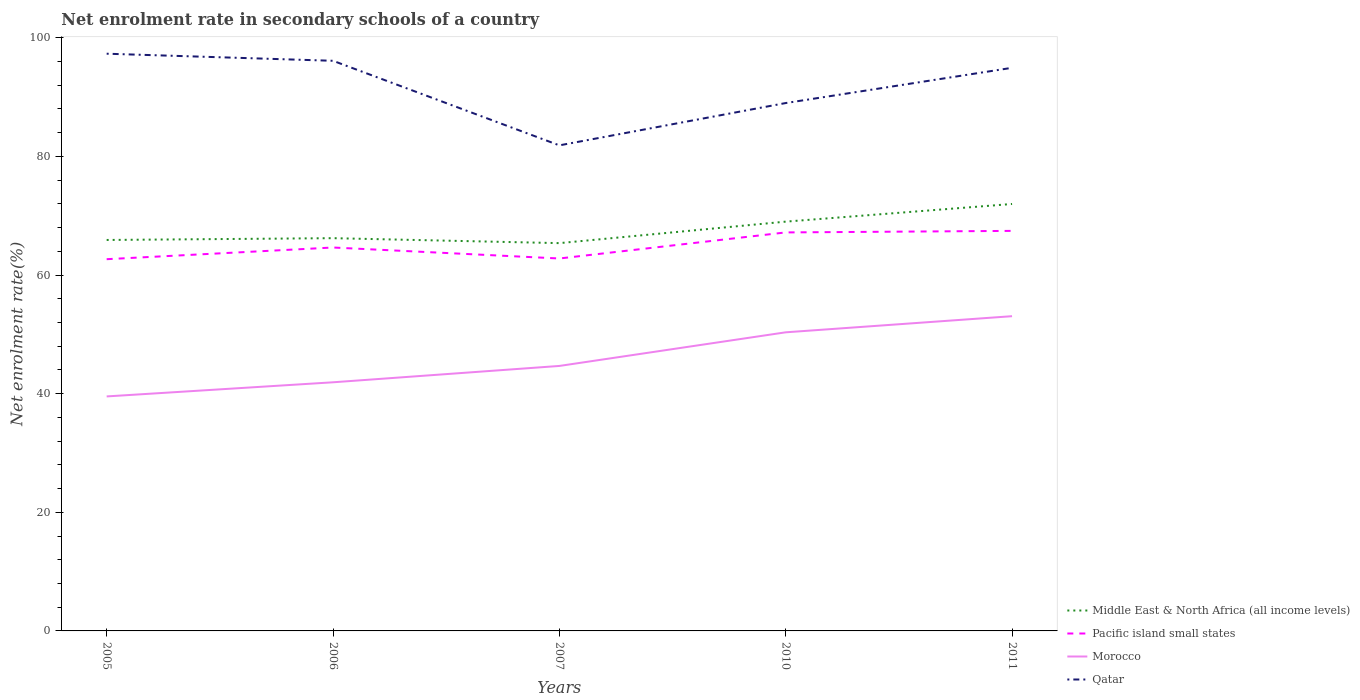How many different coloured lines are there?
Make the answer very short. 4. Does the line corresponding to Qatar intersect with the line corresponding to Morocco?
Provide a succinct answer. No. Across all years, what is the maximum net enrolment rate in secondary schools in Qatar?
Your answer should be compact. 81.87. In which year was the net enrolment rate in secondary schools in Morocco maximum?
Make the answer very short. 2005. What is the total net enrolment rate in secondary schools in Qatar in the graph?
Give a very brief answer. 2.38. What is the difference between the highest and the second highest net enrolment rate in secondary schools in Morocco?
Keep it short and to the point. 13.53. Is the net enrolment rate in secondary schools in Pacific island small states strictly greater than the net enrolment rate in secondary schools in Morocco over the years?
Make the answer very short. No. How many lines are there?
Your answer should be very brief. 4. What is the difference between two consecutive major ticks on the Y-axis?
Provide a short and direct response. 20. Are the values on the major ticks of Y-axis written in scientific E-notation?
Provide a short and direct response. No. Does the graph contain any zero values?
Keep it short and to the point. No. Does the graph contain grids?
Give a very brief answer. No. What is the title of the graph?
Offer a terse response. Net enrolment rate in secondary schools of a country. Does "Trinidad and Tobago" appear as one of the legend labels in the graph?
Your answer should be very brief. No. What is the label or title of the Y-axis?
Your answer should be very brief. Net enrolment rate(%). What is the Net enrolment rate(%) of Middle East & North Africa (all income levels) in 2005?
Provide a succinct answer. 65.92. What is the Net enrolment rate(%) in Pacific island small states in 2005?
Your response must be concise. 62.68. What is the Net enrolment rate(%) of Morocco in 2005?
Your answer should be very brief. 39.54. What is the Net enrolment rate(%) of Qatar in 2005?
Your response must be concise. 97.32. What is the Net enrolment rate(%) in Middle East & North Africa (all income levels) in 2006?
Make the answer very short. 66.22. What is the Net enrolment rate(%) in Pacific island small states in 2006?
Provide a short and direct response. 64.65. What is the Net enrolment rate(%) in Morocco in 2006?
Your answer should be very brief. 41.92. What is the Net enrolment rate(%) of Qatar in 2006?
Give a very brief answer. 96.13. What is the Net enrolment rate(%) of Middle East & North Africa (all income levels) in 2007?
Make the answer very short. 65.38. What is the Net enrolment rate(%) in Pacific island small states in 2007?
Your answer should be very brief. 62.79. What is the Net enrolment rate(%) of Morocco in 2007?
Provide a short and direct response. 44.68. What is the Net enrolment rate(%) of Qatar in 2007?
Give a very brief answer. 81.87. What is the Net enrolment rate(%) in Middle East & North Africa (all income levels) in 2010?
Provide a short and direct response. 69.01. What is the Net enrolment rate(%) in Pacific island small states in 2010?
Your response must be concise. 67.19. What is the Net enrolment rate(%) of Morocco in 2010?
Give a very brief answer. 50.35. What is the Net enrolment rate(%) of Qatar in 2010?
Your answer should be compact. 89. What is the Net enrolment rate(%) in Middle East & North Africa (all income levels) in 2011?
Offer a terse response. 71.99. What is the Net enrolment rate(%) in Pacific island small states in 2011?
Ensure brevity in your answer.  67.45. What is the Net enrolment rate(%) of Morocco in 2011?
Give a very brief answer. 53.07. What is the Net enrolment rate(%) of Qatar in 2011?
Offer a very short reply. 94.95. Across all years, what is the maximum Net enrolment rate(%) of Middle East & North Africa (all income levels)?
Provide a succinct answer. 71.99. Across all years, what is the maximum Net enrolment rate(%) in Pacific island small states?
Your answer should be compact. 67.45. Across all years, what is the maximum Net enrolment rate(%) in Morocco?
Your response must be concise. 53.07. Across all years, what is the maximum Net enrolment rate(%) of Qatar?
Offer a terse response. 97.32. Across all years, what is the minimum Net enrolment rate(%) in Middle East & North Africa (all income levels)?
Your response must be concise. 65.38. Across all years, what is the minimum Net enrolment rate(%) in Pacific island small states?
Make the answer very short. 62.68. Across all years, what is the minimum Net enrolment rate(%) in Morocco?
Give a very brief answer. 39.54. Across all years, what is the minimum Net enrolment rate(%) in Qatar?
Give a very brief answer. 81.87. What is the total Net enrolment rate(%) in Middle East & North Africa (all income levels) in the graph?
Keep it short and to the point. 338.52. What is the total Net enrolment rate(%) of Pacific island small states in the graph?
Your answer should be very brief. 324.76. What is the total Net enrolment rate(%) in Morocco in the graph?
Give a very brief answer. 229.55. What is the total Net enrolment rate(%) in Qatar in the graph?
Provide a short and direct response. 459.27. What is the difference between the Net enrolment rate(%) of Middle East & North Africa (all income levels) in 2005 and that in 2006?
Offer a very short reply. -0.3. What is the difference between the Net enrolment rate(%) in Pacific island small states in 2005 and that in 2006?
Your answer should be very brief. -1.97. What is the difference between the Net enrolment rate(%) of Morocco in 2005 and that in 2006?
Your response must be concise. -2.38. What is the difference between the Net enrolment rate(%) of Qatar in 2005 and that in 2006?
Provide a short and direct response. 1.19. What is the difference between the Net enrolment rate(%) of Middle East & North Africa (all income levels) in 2005 and that in 2007?
Provide a succinct answer. 0.53. What is the difference between the Net enrolment rate(%) of Pacific island small states in 2005 and that in 2007?
Make the answer very short. -0.12. What is the difference between the Net enrolment rate(%) in Morocco in 2005 and that in 2007?
Keep it short and to the point. -5.14. What is the difference between the Net enrolment rate(%) of Qatar in 2005 and that in 2007?
Your response must be concise. 15.45. What is the difference between the Net enrolment rate(%) of Middle East & North Africa (all income levels) in 2005 and that in 2010?
Your answer should be very brief. -3.09. What is the difference between the Net enrolment rate(%) of Pacific island small states in 2005 and that in 2010?
Ensure brevity in your answer.  -4.51. What is the difference between the Net enrolment rate(%) in Morocco in 2005 and that in 2010?
Your answer should be compact. -10.81. What is the difference between the Net enrolment rate(%) in Qatar in 2005 and that in 2010?
Keep it short and to the point. 8.32. What is the difference between the Net enrolment rate(%) in Middle East & North Africa (all income levels) in 2005 and that in 2011?
Your answer should be compact. -6.07. What is the difference between the Net enrolment rate(%) in Pacific island small states in 2005 and that in 2011?
Your answer should be compact. -4.77. What is the difference between the Net enrolment rate(%) in Morocco in 2005 and that in 2011?
Provide a short and direct response. -13.53. What is the difference between the Net enrolment rate(%) in Qatar in 2005 and that in 2011?
Offer a very short reply. 2.38. What is the difference between the Net enrolment rate(%) in Middle East & North Africa (all income levels) in 2006 and that in 2007?
Offer a very short reply. 0.84. What is the difference between the Net enrolment rate(%) of Pacific island small states in 2006 and that in 2007?
Give a very brief answer. 1.85. What is the difference between the Net enrolment rate(%) of Morocco in 2006 and that in 2007?
Keep it short and to the point. -2.76. What is the difference between the Net enrolment rate(%) of Qatar in 2006 and that in 2007?
Make the answer very short. 14.26. What is the difference between the Net enrolment rate(%) of Middle East & North Africa (all income levels) in 2006 and that in 2010?
Provide a short and direct response. -2.79. What is the difference between the Net enrolment rate(%) in Pacific island small states in 2006 and that in 2010?
Offer a terse response. -2.54. What is the difference between the Net enrolment rate(%) in Morocco in 2006 and that in 2010?
Provide a succinct answer. -8.43. What is the difference between the Net enrolment rate(%) of Qatar in 2006 and that in 2010?
Your response must be concise. 7.12. What is the difference between the Net enrolment rate(%) of Middle East & North Africa (all income levels) in 2006 and that in 2011?
Your response must be concise. -5.77. What is the difference between the Net enrolment rate(%) in Pacific island small states in 2006 and that in 2011?
Ensure brevity in your answer.  -2.8. What is the difference between the Net enrolment rate(%) of Morocco in 2006 and that in 2011?
Keep it short and to the point. -11.15. What is the difference between the Net enrolment rate(%) in Qatar in 2006 and that in 2011?
Ensure brevity in your answer.  1.18. What is the difference between the Net enrolment rate(%) in Middle East & North Africa (all income levels) in 2007 and that in 2010?
Offer a very short reply. -3.63. What is the difference between the Net enrolment rate(%) in Pacific island small states in 2007 and that in 2010?
Keep it short and to the point. -4.4. What is the difference between the Net enrolment rate(%) of Morocco in 2007 and that in 2010?
Your answer should be very brief. -5.67. What is the difference between the Net enrolment rate(%) in Qatar in 2007 and that in 2010?
Offer a very short reply. -7.13. What is the difference between the Net enrolment rate(%) in Middle East & North Africa (all income levels) in 2007 and that in 2011?
Make the answer very short. -6.6. What is the difference between the Net enrolment rate(%) of Pacific island small states in 2007 and that in 2011?
Your answer should be very brief. -4.66. What is the difference between the Net enrolment rate(%) of Morocco in 2007 and that in 2011?
Offer a terse response. -8.39. What is the difference between the Net enrolment rate(%) in Qatar in 2007 and that in 2011?
Keep it short and to the point. -13.08. What is the difference between the Net enrolment rate(%) of Middle East & North Africa (all income levels) in 2010 and that in 2011?
Offer a terse response. -2.98. What is the difference between the Net enrolment rate(%) in Pacific island small states in 2010 and that in 2011?
Ensure brevity in your answer.  -0.26. What is the difference between the Net enrolment rate(%) of Morocco in 2010 and that in 2011?
Offer a terse response. -2.72. What is the difference between the Net enrolment rate(%) of Qatar in 2010 and that in 2011?
Keep it short and to the point. -5.94. What is the difference between the Net enrolment rate(%) in Middle East & North Africa (all income levels) in 2005 and the Net enrolment rate(%) in Pacific island small states in 2006?
Offer a terse response. 1.27. What is the difference between the Net enrolment rate(%) in Middle East & North Africa (all income levels) in 2005 and the Net enrolment rate(%) in Morocco in 2006?
Provide a succinct answer. 24. What is the difference between the Net enrolment rate(%) of Middle East & North Africa (all income levels) in 2005 and the Net enrolment rate(%) of Qatar in 2006?
Give a very brief answer. -30.21. What is the difference between the Net enrolment rate(%) of Pacific island small states in 2005 and the Net enrolment rate(%) of Morocco in 2006?
Offer a terse response. 20.76. What is the difference between the Net enrolment rate(%) of Pacific island small states in 2005 and the Net enrolment rate(%) of Qatar in 2006?
Provide a short and direct response. -33.45. What is the difference between the Net enrolment rate(%) in Morocco in 2005 and the Net enrolment rate(%) in Qatar in 2006?
Make the answer very short. -56.59. What is the difference between the Net enrolment rate(%) in Middle East & North Africa (all income levels) in 2005 and the Net enrolment rate(%) in Pacific island small states in 2007?
Ensure brevity in your answer.  3.12. What is the difference between the Net enrolment rate(%) of Middle East & North Africa (all income levels) in 2005 and the Net enrolment rate(%) of Morocco in 2007?
Keep it short and to the point. 21.24. What is the difference between the Net enrolment rate(%) in Middle East & North Africa (all income levels) in 2005 and the Net enrolment rate(%) in Qatar in 2007?
Make the answer very short. -15.95. What is the difference between the Net enrolment rate(%) of Pacific island small states in 2005 and the Net enrolment rate(%) of Morocco in 2007?
Provide a succinct answer. 18. What is the difference between the Net enrolment rate(%) of Pacific island small states in 2005 and the Net enrolment rate(%) of Qatar in 2007?
Offer a very short reply. -19.19. What is the difference between the Net enrolment rate(%) in Morocco in 2005 and the Net enrolment rate(%) in Qatar in 2007?
Ensure brevity in your answer.  -42.33. What is the difference between the Net enrolment rate(%) in Middle East & North Africa (all income levels) in 2005 and the Net enrolment rate(%) in Pacific island small states in 2010?
Ensure brevity in your answer.  -1.27. What is the difference between the Net enrolment rate(%) in Middle East & North Africa (all income levels) in 2005 and the Net enrolment rate(%) in Morocco in 2010?
Keep it short and to the point. 15.57. What is the difference between the Net enrolment rate(%) in Middle East & North Africa (all income levels) in 2005 and the Net enrolment rate(%) in Qatar in 2010?
Your answer should be very brief. -23.09. What is the difference between the Net enrolment rate(%) of Pacific island small states in 2005 and the Net enrolment rate(%) of Morocco in 2010?
Offer a very short reply. 12.33. What is the difference between the Net enrolment rate(%) in Pacific island small states in 2005 and the Net enrolment rate(%) in Qatar in 2010?
Your answer should be compact. -26.33. What is the difference between the Net enrolment rate(%) in Morocco in 2005 and the Net enrolment rate(%) in Qatar in 2010?
Give a very brief answer. -49.47. What is the difference between the Net enrolment rate(%) of Middle East & North Africa (all income levels) in 2005 and the Net enrolment rate(%) of Pacific island small states in 2011?
Make the answer very short. -1.53. What is the difference between the Net enrolment rate(%) of Middle East & North Africa (all income levels) in 2005 and the Net enrolment rate(%) of Morocco in 2011?
Your response must be concise. 12.85. What is the difference between the Net enrolment rate(%) of Middle East & North Africa (all income levels) in 2005 and the Net enrolment rate(%) of Qatar in 2011?
Offer a terse response. -29.03. What is the difference between the Net enrolment rate(%) in Pacific island small states in 2005 and the Net enrolment rate(%) in Morocco in 2011?
Make the answer very short. 9.61. What is the difference between the Net enrolment rate(%) of Pacific island small states in 2005 and the Net enrolment rate(%) of Qatar in 2011?
Your response must be concise. -32.27. What is the difference between the Net enrolment rate(%) in Morocco in 2005 and the Net enrolment rate(%) in Qatar in 2011?
Your response must be concise. -55.41. What is the difference between the Net enrolment rate(%) of Middle East & North Africa (all income levels) in 2006 and the Net enrolment rate(%) of Pacific island small states in 2007?
Provide a succinct answer. 3.43. What is the difference between the Net enrolment rate(%) of Middle East & North Africa (all income levels) in 2006 and the Net enrolment rate(%) of Morocco in 2007?
Your answer should be very brief. 21.54. What is the difference between the Net enrolment rate(%) in Middle East & North Africa (all income levels) in 2006 and the Net enrolment rate(%) in Qatar in 2007?
Your answer should be very brief. -15.65. What is the difference between the Net enrolment rate(%) in Pacific island small states in 2006 and the Net enrolment rate(%) in Morocco in 2007?
Offer a very short reply. 19.97. What is the difference between the Net enrolment rate(%) of Pacific island small states in 2006 and the Net enrolment rate(%) of Qatar in 2007?
Offer a terse response. -17.22. What is the difference between the Net enrolment rate(%) of Morocco in 2006 and the Net enrolment rate(%) of Qatar in 2007?
Provide a short and direct response. -39.95. What is the difference between the Net enrolment rate(%) in Middle East & North Africa (all income levels) in 2006 and the Net enrolment rate(%) in Pacific island small states in 2010?
Provide a succinct answer. -0.97. What is the difference between the Net enrolment rate(%) of Middle East & North Africa (all income levels) in 2006 and the Net enrolment rate(%) of Morocco in 2010?
Ensure brevity in your answer.  15.87. What is the difference between the Net enrolment rate(%) of Middle East & North Africa (all income levels) in 2006 and the Net enrolment rate(%) of Qatar in 2010?
Offer a terse response. -22.78. What is the difference between the Net enrolment rate(%) of Pacific island small states in 2006 and the Net enrolment rate(%) of Morocco in 2010?
Provide a succinct answer. 14.3. What is the difference between the Net enrolment rate(%) of Pacific island small states in 2006 and the Net enrolment rate(%) of Qatar in 2010?
Ensure brevity in your answer.  -24.36. What is the difference between the Net enrolment rate(%) in Morocco in 2006 and the Net enrolment rate(%) in Qatar in 2010?
Keep it short and to the point. -47.08. What is the difference between the Net enrolment rate(%) in Middle East & North Africa (all income levels) in 2006 and the Net enrolment rate(%) in Pacific island small states in 2011?
Make the answer very short. -1.23. What is the difference between the Net enrolment rate(%) of Middle East & North Africa (all income levels) in 2006 and the Net enrolment rate(%) of Morocco in 2011?
Make the answer very short. 13.15. What is the difference between the Net enrolment rate(%) of Middle East & North Africa (all income levels) in 2006 and the Net enrolment rate(%) of Qatar in 2011?
Ensure brevity in your answer.  -28.73. What is the difference between the Net enrolment rate(%) in Pacific island small states in 2006 and the Net enrolment rate(%) in Morocco in 2011?
Keep it short and to the point. 11.58. What is the difference between the Net enrolment rate(%) in Pacific island small states in 2006 and the Net enrolment rate(%) in Qatar in 2011?
Provide a short and direct response. -30.3. What is the difference between the Net enrolment rate(%) of Morocco in 2006 and the Net enrolment rate(%) of Qatar in 2011?
Provide a short and direct response. -53.02. What is the difference between the Net enrolment rate(%) in Middle East & North Africa (all income levels) in 2007 and the Net enrolment rate(%) in Pacific island small states in 2010?
Ensure brevity in your answer.  -1.81. What is the difference between the Net enrolment rate(%) of Middle East & North Africa (all income levels) in 2007 and the Net enrolment rate(%) of Morocco in 2010?
Offer a very short reply. 15.04. What is the difference between the Net enrolment rate(%) of Middle East & North Africa (all income levels) in 2007 and the Net enrolment rate(%) of Qatar in 2010?
Offer a very short reply. -23.62. What is the difference between the Net enrolment rate(%) in Pacific island small states in 2007 and the Net enrolment rate(%) in Morocco in 2010?
Your response must be concise. 12.45. What is the difference between the Net enrolment rate(%) in Pacific island small states in 2007 and the Net enrolment rate(%) in Qatar in 2010?
Your answer should be compact. -26.21. What is the difference between the Net enrolment rate(%) of Morocco in 2007 and the Net enrolment rate(%) of Qatar in 2010?
Give a very brief answer. -44.33. What is the difference between the Net enrolment rate(%) in Middle East & North Africa (all income levels) in 2007 and the Net enrolment rate(%) in Pacific island small states in 2011?
Your response must be concise. -2.07. What is the difference between the Net enrolment rate(%) in Middle East & North Africa (all income levels) in 2007 and the Net enrolment rate(%) in Morocco in 2011?
Offer a terse response. 12.32. What is the difference between the Net enrolment rate(%) of Middle East & North Africa (all income levels) in 2007 and the Net enrolment rate(%) of Qatar in 2011?
Your answer should be compact. -29.56. What is the difference between the Net enrolment rate(%) in Pacific island small states in 2007 and the Net enrolment rate(%) in Morocco in 2011?
Your response must be concise. 9.73. What is the difference between the Net enrolment rate(%) of Pacific island small states in 2007 and the Net enrolment rate(%) of Qatar in 2011?
Provide a succinct answer. -32.15. What is the difference between the Net enrolment rate(%) of Morocco in 2007 and the Net enrolment rate(%) of Qatar in 2011?
Keep it short and to the point. -50.27. What is the difference between the Net enrolment rate(%) of Middle East & North Africa (all income levels) in 2010 and the Net enrolment rate(%) of Pacific island small states in 2011?
Provide a short and direct response. 1.56. What is the difference between the Net enrolment rate(%) in Middle East & North Africa (all income levels) in 2010 and the Net enrolment rate(%) in Morocco in 2011?
Your answer should be compact. 15.94. What is the difference between the Net enrolment rate(%) in Middle East & North Africa (all income levels) in 2010 and the Net enrolment rate(%) in Qatar in 2011?
Your answer should be very brief. -25.94. What is the difference between the Net enrolment rate(%) of Pacific island small states in 2010 and the Net enrolment rate(%) of Morocco in 2011?
Your answer should be compact. 14.12. What is the difference between the Net enrolment rate(%) in Pacific island small states in 2010 and the Net enrolment rate(%) in Qatar in 2011?
Make the answer very short. -27.75. What is the difference between the Net enrolment rate(%) of Morocco in 2010 and the Net enrolment rate(%) of Qatar in 2011?
Keep it short and to the point. -44.6. What is the average Net enrolment rate(%) in Middle East & North Africa (all income levels) per year?
Keep it short and to the point. 67.7. What is the average Net enrolment rate(%) of Pacific island small states per year?
Give a very brief answer. 64.95. What is the average Net enrolment rate(%) of Morocco per year?
Provide a succinct answer. 45.91. What is the average Net enrolment rate(%) of Qatar per year?
Offer a very short reply. 91.85. In the year 2005, what is the difference between the Net enrolment rate(%) of Middle East & North Africa (all income levels) and Net enrolment rate(%) of Pacific island small states?
Give a very brief answer. 3.24. In the year 2005, what is the difference between the Net enrolment rate(%) of Middle East & North Africa (all income levels) and Net enrolment rate(%) of Morocco?
Give a very brief answer. 26.38. In the year 2005, what is the difference between the Net enrolment rate(%) in Middle East & North Africa (all income levels) and Net enrolment rate(%) in Qatar?
Ensure brevity in your answer.  -31.4. In the year 2005, what is the difference between the Net enrolment rate(%) of Pacific island small states and Net enrolment rate(%) of Morocco?
Your answer should be compact. 23.14. In the year 2005, what is the difference between the Net enrolment rate(%) in Pacific island small states and Net enrolment rate(%) in Qatar?
Offer a terse response. -34.65. In the year 2005, what is the difference between the Net enrolment rate(%) of Morocco and Net enrolment rate(%) of Qatar?
Offer a very short reply. -57.78. In the year 2006, what is the difference between the Net enrolment rate(%) in Middle East & North Africa (all income levels) and Net enrolment rate(%) in Pacific island small states?
Keep it short and to the point. 1.57. In the year 2006, what is the difference between the Net enrolment rate(%) of Middle East & North Africa (all income levels) and Net enrolment rate(%) of Morocco?
Ensure brevity in your answer.  24.3. In the year 2006, what is the difference between the Net enrolment rate(%) in Middle East & North Africa (all income levels) and Net enrolment rate(%) in Qatar?
Your answer should be very brief. -29.91. In the year 2006, what is the difference between the Net enrolment rate(%) in Pacific island small states and Net enrolment rate(%) in Morocco?
Your answer should be very brief. 22.73. In the year 2006, what is the difference between the Net enrolment rate(%) in Pacific island small states and Net enrolment rate(%) in Qatar?
Offer a terse response. -31.48. In the year 2006, what is the difference between the Net enrolment rate(%) in Morocco and Net enrolment rate(%) in Qatar?
Provide a short and direct response. -54.21. In the year 2007, what is the difference between the Net enrolment rate(%) in Middle East & North Africa (all income levels) and Net enrolment rate(%) in Pacific island small states?
Give a very brief answer. 2.59. In the year 2007, what is the difference between the Net enrolment rate(%) in Middle East & North Africa (all income levels) and Net enrolment rate(%) in Morocco?
Offer a terse response. 20.71. In the year 2007, what is the difference between the Net enrolment rate(%) of Middle East & North Africa (all income levels) and Net enrolment rate(%) of Qatar?
Ensure brevity in your answer.  -16.49. In the year 2007, what is the difference between the Net enrolment rate(%) of Pacific island small states and Net enrolment rate(%) of Morocco?
Your answer should be very brief. 18.12. In the year 2007, what is the difference between the Net enrolment rate(%) of Pacific island small states and Net enrolment rate(%) of Qatar?
Ensure brevity in your answer.  -19.07. In the year 2007, what is the difference between the Net enrolment rate(%) of Morocco and Net enrolment rate(%) of Qatar?
Make the answer very short. -37.19. In the year 2010, what is the difference between the Net enrolment rate(%) of Middle East & North Africa (all income levels) and Net enrolment rate(%) of Pacific island small states?
Offer a very short reply. 1.82. In the year 2010, what is the difference between the Net enrolment rate(%) of Middle East & North Africa (all income levels) and Net enrolment rate(%) of Morocco?
Offer a very short reply. 18.66. In the year 2010, what is the difference between the Net enrolment rate(%) in Middle East & North Africa (all income levels) and Net enrolment rate(%) in Qatar?
Provide a short and direct response. -19.99. In the year 2010, what is the difference between the Net enrolment rate(%) of Pacific island small states and Net enrolment rate(%) of Morocco?
Provide a short and direct response. 16.84. In the year 2010, what is the difference between the Net enrolment rate(%) in Pacific island small states and Net enrolment rate(%) in Qatar?
Give a very brief answer. -21.81. In the year 2010, what is the difference between the Net enrolment rate(%) in Morocco and Net enrolment rate(%) in Qatar?
Keep it short and to the point. -38.66. In the year 2011, what is the difference between the Net enrolment rate(%) of Middle East & North Africa (all income levels) and Net enrolment rate(%) of Pacific island small states?
Offer a terse response. 4.54. In the year 2011, what is the difference between the Net enrolment rate(%) in Middle East & North Africa (all income levels) and Net enrolment rate(%) in Morocco?
Your answer should be very brief. 18.92. In the year 2011, what is the difference between the Net enrolment rate(%) of Middle East & North Africa (all income levels) and Net enrolment rate(%) of Qatar?
Give a very brief answer. -22.96. In the year 2011, what is the difference between the Net enrolment rate(%) in Pacific island small states and Net enrolment rate(%) in Morocco?
Your answer should be very brief. 14.38. In the year 2011, what is the difference between the Net enrolment rate(%) in Pacific island small states and Net enrolment rate(%) in Qatar?
Your response must be concise. -27.5. In the year 2011, what is the difference between the Net enrolment rate(%) of Morocco and Net enrolment rate(%) of Qatar?
Offer a very short reply. -41.88. What is the ratio of the Net enrolment rate(%) in Middle East & North Africa (all income levels) in 2005 to that in 2006?
Your answer should be compact. 1. What is the ratio of the Net enrolment rate(%) of Pacific island small states in 2005 to that in 2006?
Provide a short and direct response. 0.97. What is the ratio of the Net enrolment rate(%) of Morocco in 2005 to that in 2006?
Your answer should be very brief. 0.94. What is the ratio of the Net enrolment rate(%) in Qatar in 2005 to that in 2006?
Offer a terse response. 1.01. What is the ratio of the Net enrolment rate(%) in Middle East & North Africa (all income levels) in 2005 to that in 2007?
Ensure brevity in your answer.  1.01. What is the ratio of the Net enrolment rate(%) in Morocco in 2005 to that in 2007?
Your answer should be very brief. 0.89. What is the ratio of the Net enrolment rate(%) in Qatar in 2005 to that in 2007?
Your response must be concise. 1.19. What is the ratio of the Net enrolment rate(%) of Middle East & North Africa (all income levels) in 2005 to that in 2010?
Give a very brief answer. 0.96. What is the ratio of the Net enrolment rate(%) in Pacific island small states in 2005 to that in 2010?
Your response must be concise. 0.93. What is the ratio of the Net enrolment rate(%) of Morocco in 2005 to that in 2010?
Make the answer very short. 0.79. What is the ratio of the Net enrolment rate(%) in Qatar in 2005 to that in 2010?
Make the answer very short. 1.09. What is the ratio of the Net enrolment rate(%) in Middle East & North Africa (all income levels) in 2005 to that in 2011?
Your answer should be compact. 0.92. What is the ratio of the Net enrolment rate(%) in Pacific island small states in 2005 to that in 2011?
Your answer should be very brief. 0.93. What is the ratio of the Net enrolment rate(%) in Morocco in 2005 to that in 2011?
Keep it short and to the point. 0.75. What is the ratio of the Net enrolment rate(%) in Middle East & North Africa (all income levels) in 2006 to that in 2007?
Ensure brevity in your answer.  1.01. What is the ratio of the Net enrolment rate(%) of Pacific island small states in 2006 to that in 2007?
Make the answer very short. 1.03. What is the ratio of the Net enrolment rate(%) of Morocco in 2006 to that in 2007?
Give a very brief answer. 0.94. What is the ratio of the Net enrolment rate(%) of Qatar in 2006 to that in 2007?
Offer a very short reply. 1.17. What is the ratio of the Net enrolment rate(%) in Middle East & North Africa (all income levels) in 2006 to that in 2010?
Your answer should be compact. 0.96. What is the ratio of the Net enrolment rate(%) of Pacific island small states in 2006 to that in 2010?
Make the answer very short. 0.96. What is the ratio of the Net enrolment rate(%) of Morocco in 2006 to that in 2010?
Your answer should be compact. 0.83. What is the ratio of the Net enrolment rate(%) in Middle East & North Africa (all income levels) in 2006 to that in 2011?
Keep it short and to the point. 0.92. What is the ratio of the Net enrolment rate(%) in Pacific island small states in 2006 to that in 2011?
Your answer should be compact. 0.96. What is the ratio of the Net enrolment rate(%) in Morocco in 2006 to that in 2011?
Keep it short and to the point. 0.79. What is the ratio of the Net enrolment rate(%) of Qatar in 2006 to that in 2011?
Offer a very short reply. 1.01. What is the ratio of the Net enrolment rate(%) of Middle East & North Africa (all income levels) in 2007 to that in 2010?
Your response must be concise. 0.95. What is the ratio of the Net enrolment rate(%) of Pacific island small states in 2007 to that in 2010?
Keep it short and to the point. 0.93. What is the ratio of the Net enrolment rate(%) of Morocco in 2007 to that in 2010?
Your answer should be compact. 0.89. What is the ratio of the Net enrolment rate(%) of Qatar in 2007 to that in 2010?
Your answer should be very brief. 0.92. What is the ratio of the Net enrolment rate(%) in Middle East & North Africa (all income levels) in 2007 to that in 2011?
Your answer should be compact. 0.91. What is the ratio of the Net enrolment rate(%) of Morocco in 2007 to that in 2011?
Give a very brief answer. 0.84. What is the ratio of the Net enrolment rate(%) in Qatar in 2007 to that in 2011?
Your answer should be very brief. 0.86. What is the ratio of the Net enrolment rate(%) of Middle East & North Africa (all income levels) in 2010 to that in 2011?
Your answer should be very brief. 0.96. What is the ratio of the Net enrolment rate(%) of Pacific island small states in 2010 to that in 2011?
Give a very brief answer. 1. What is the ratio of the Net enrolment rate(%) in Morocco in 2010 to that in 2011?
Provide a short and direct response. 0.95. What is the ratio of the Net enrolment rate(%) of Qatar in 2010 to that in 2011?
Your answer should be compact. 0.94. What is the difference between the highest and the second highest Net enrolment rate(%) of Middle East & North Africa (all income levels)?
Your response must be concise. 2.98. What is the difference between the highest and the second highest Net enrolment rate(%) in Pacific island small states?
Your answer should be very brief. 0.26. What is the difference between the highest and the second highest Net enrolment rate(%) of Morocco?
Provide a short and direct response. 2.72. What is the difference between the highest and the second highest Net enrolment rate(%) in Qatar?
Offer a very short reply. 1.19. What is the difference between the highest and the lowest Net enrolment rate(%) of Middle East & North Africa (all income levels)?
Make the answer very short. 6.6. What is the difference between the highest and the lowest Net enrolment rate(%) in Pacific island small states?
Ensure brevity in your answer.  4.77. What is the difference between the highest and the lowest Net enrolment rate(%) of Morocco?
Your answer should be compact. 13.53. What is the difference between the highest and the lowest Net enrolment rate(%) in Qatar?
Offer a terse response. 15.45. 